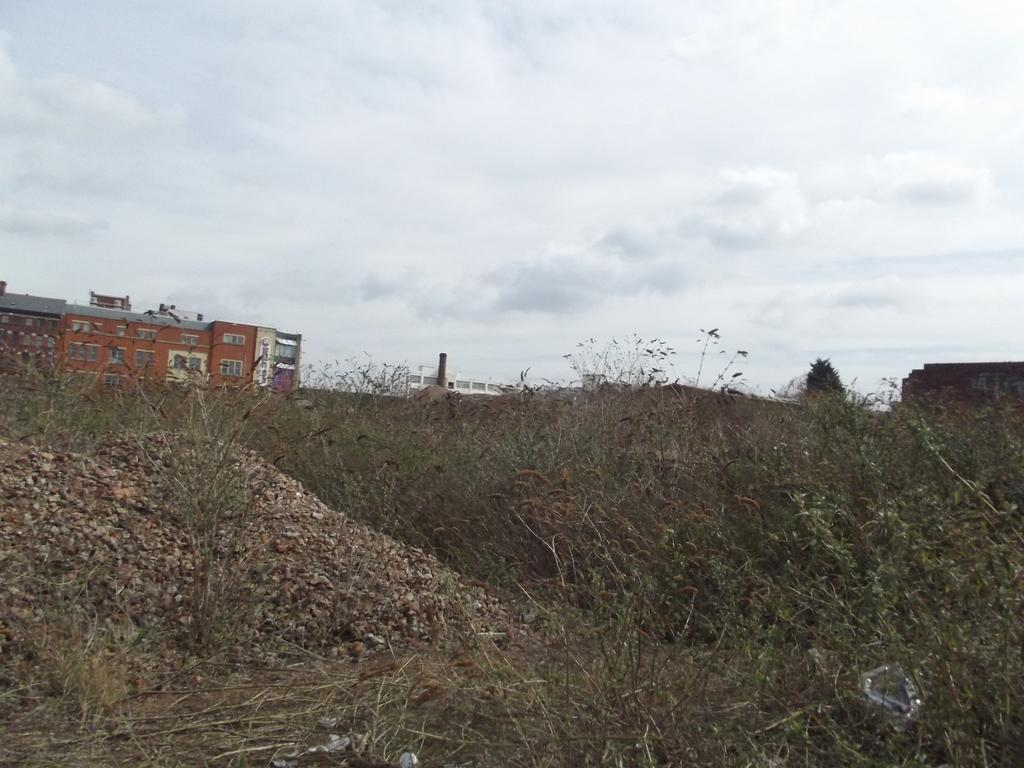What type of structures can be seen in the image? There are buildings in the image. What type of vegetation is present in the image? There is a tree and plants in the image. What is the condition of the sky in the image? The sky is cloudy in the image. What type of sack can be seen hanging from the tree in the image? There is no sack hanging from the tree in the image; only a tree and plants are present. Can you see a band playing music in the image? There is no band playing music in the image; the image only features buildings, a tree, plants, and a cloudy sky. 